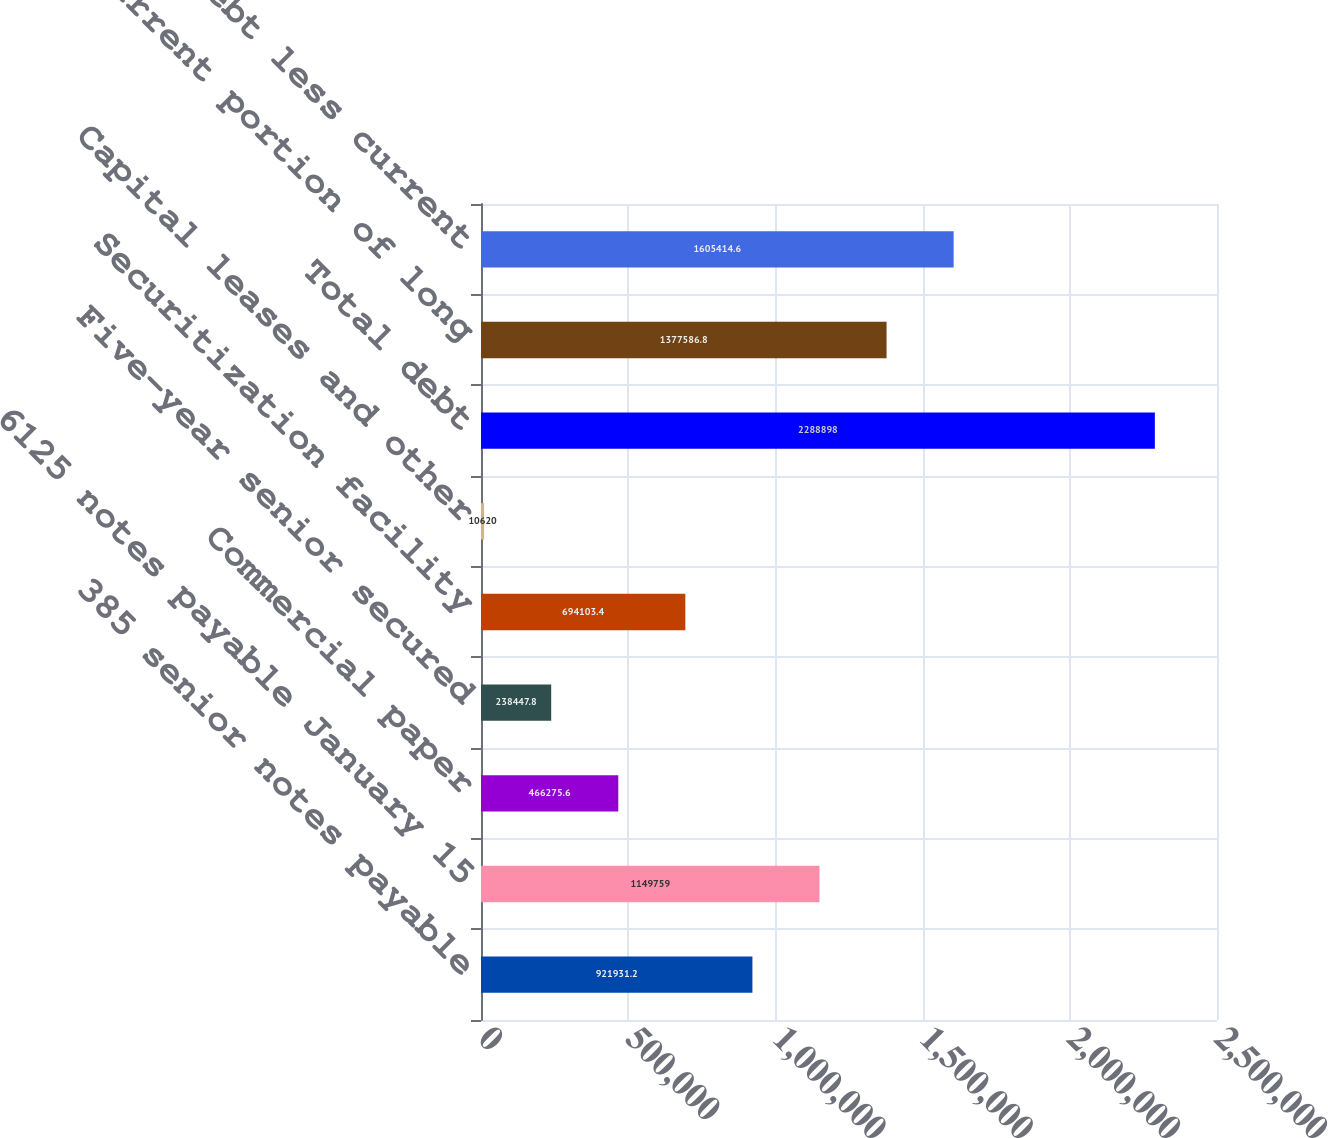Convert chart to OTSL. <chart><loc_0><loc_0><loc_500><loc_500><bar_chart><fcel>385 senior notes payable<fcel>6125 notes payable January 15<fcel>Commercial paper<fcel>Five-year senior secured<fcel>Securitization facility<fcel>Capital leases and other<fcel>Total debt<fcel>Less current portion of long<fcel>Long-term debt less current<nl><fcel>921931<fcel>1.14976e+06<fcel>466276<fcel>238448<fcel>694103<fcel>10620<fcel>2.2889e+06<fcel>1.37759e+06<fcel>1.60541e+06<nl></chart> 